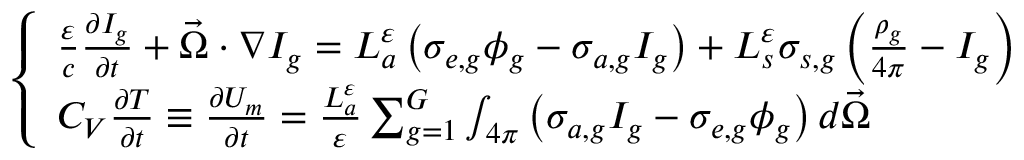<formula> <loc_0><loc_0><loc_500><loc_500>\left \{ \begin{array} { l } { { \frac { \varepsilon } { c } \frac { \partial I _ { g } } { \partial t } + \vec { \Omega } \cdot \nabla I _ { g } = L _ { a } ^ { \varepsilon } \left ( \sigma _ { e , g } \phi _ { g } - \sigma _ { a , g } I _ { g } \right ) + L _ { s } ^ { \varepsilon } \sigma _ { s , g } \left ( \frac { \rho _ { g } } { 4 \pi } - I _ { g } \right ) } } \\ { { C _ { V } \frac { \partial T } { \partial t } \equiv \frac { \partial U _ { m } } { \partial t } = \frac { L _ { a } ^ { \varepsilon } } { \varepsilon } \sum _ { g = 1 } ^ { G } \int _ { 4 \pi } \left ( \sigma _ { a , g } I _ { g } - \sigma _ { e , g } \phi _ { g } \right ) d \vec { \Omega } } } \end{array}</formula> 